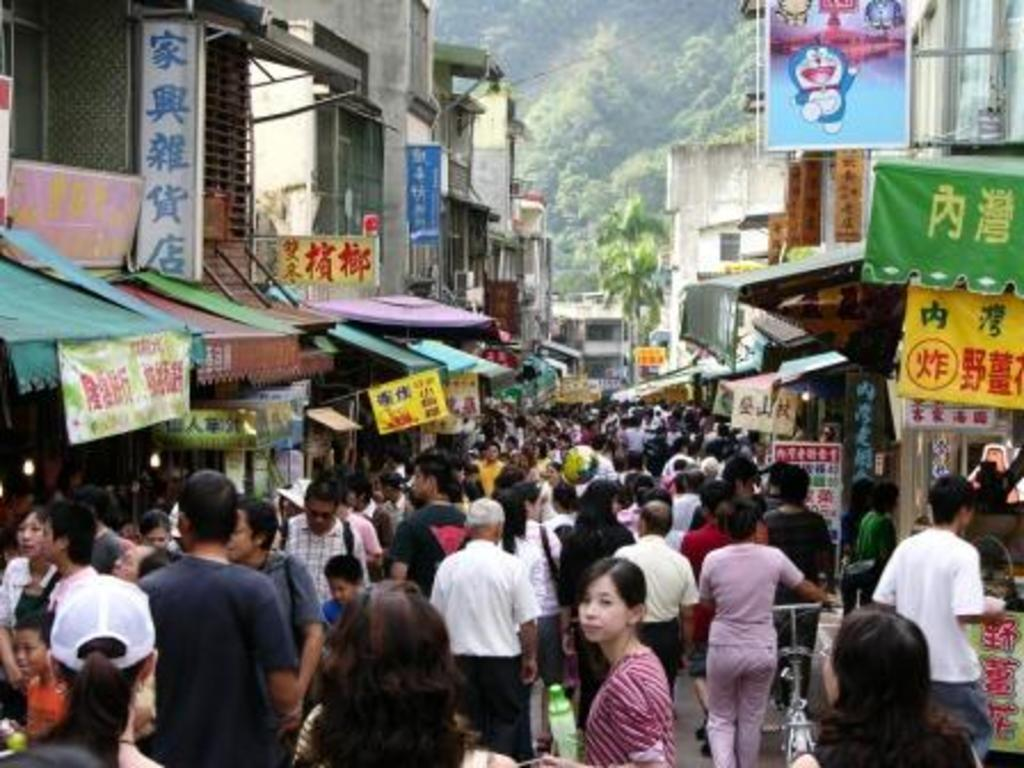What are the people in the image doing? There are people walking and standing in the image. What can be seen on the boards in the image? The boards in the image have text on them. What type of structures are visible in the image? There are buildings visible in the image. What type of vegetation is present in the image? There are trees in the image. What type of alarm can be heard in the image? There is no alarm present in the image, as it is a visual representation and does not include sound. 